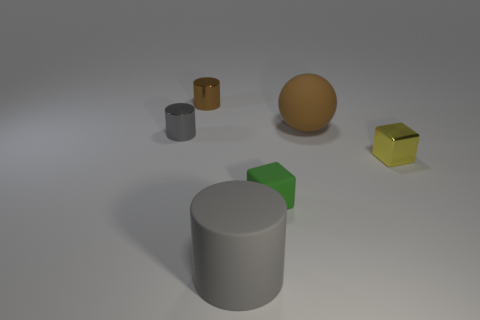What number of blocks are either tiny gray metallic things or big objects?
Give a very brief answer. 0. What color is the big thing to the right of the tiny green object?
Your answer should be very brief. Brown. What shape is the tiny thing that is the same color as the large rubber sphere?
Your answer should be compact. Cylinder. What number of shiny cylinders have the same size as the gray rubber object?
Make the answer very short. 0. Do the metallic object that is on the right side of the large brown object and the tiny brown object that is behind the tiny yellow metallic thing have the same shape?
Keep it short and to the point. No. The gray thing on the left side of the tiny cylinder right of the gray object that is behind the small yellow metallic object is made of what material?
Give a very brief answer. Metal. What shape is the gray thing that is the same size as the shiny cube?
Offer a terse response. Cylinder. Are there any metal cylinders of the same color as the big rubber cylinder?
Offer a terse response. Yes. What size is the brown metallic thing?
Your answer should be compact. Small. Is the material of the tiny brown thing the same as the green block?
Keep it short and to the point. No. 